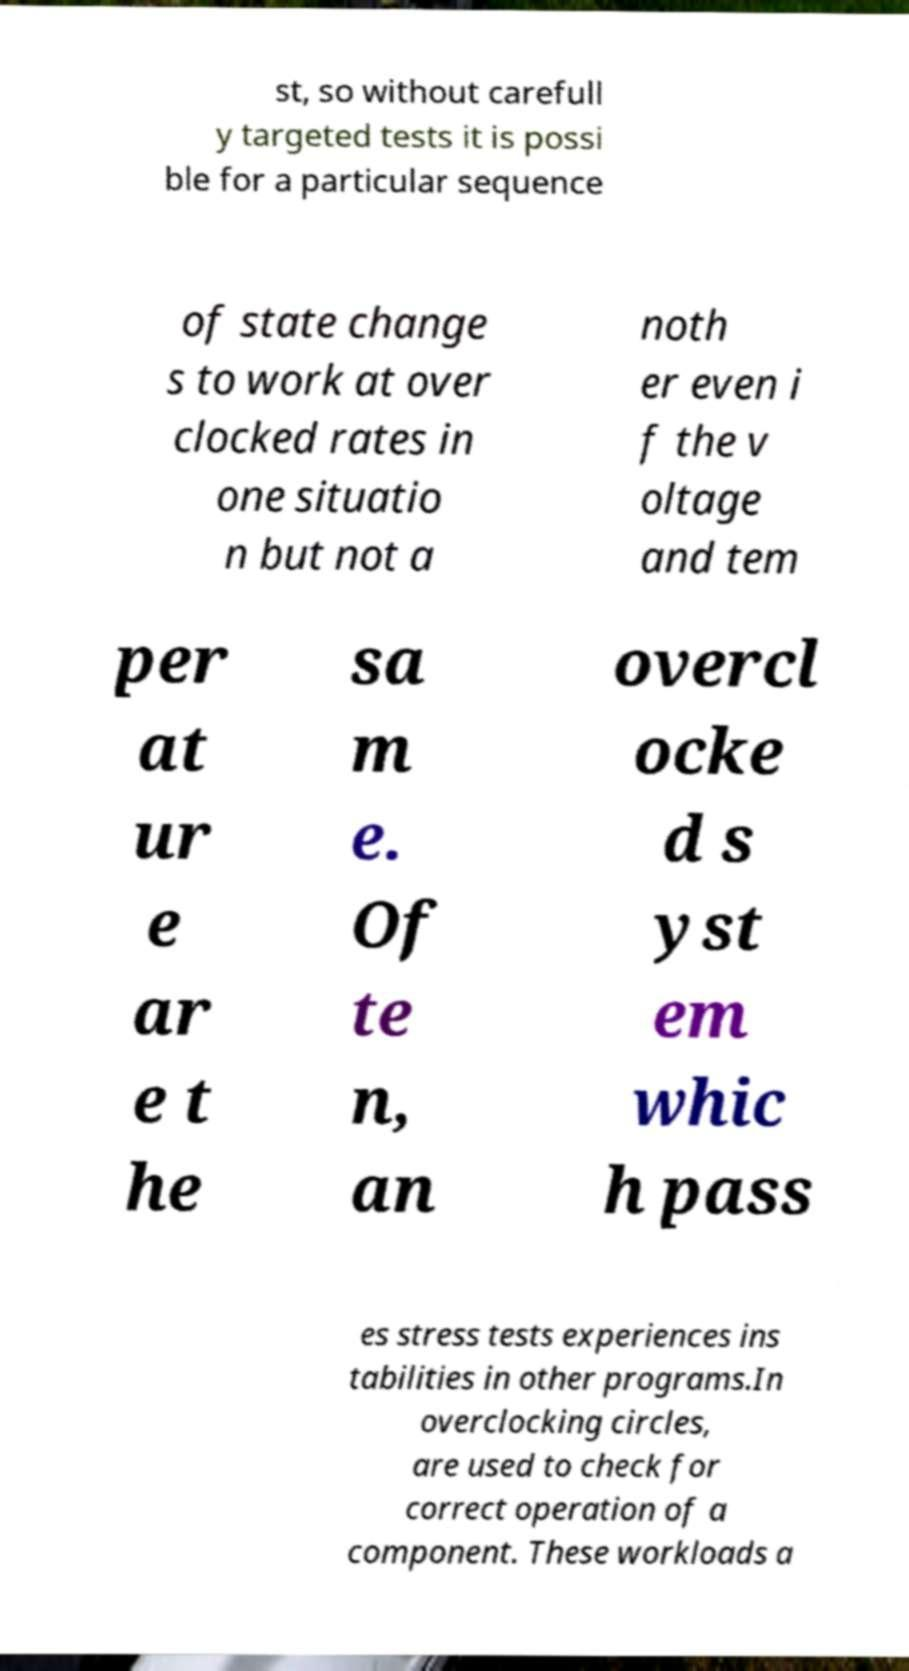I need the written content from this picture converted into text. Can you do that? st, so without carefull y targeted tests it is possi ble for a particular sequence of state change s to work at over clocked rates in one situatio n but not a noth er even i f the v oltage and tem per at ur e ar e t he sa m e. Of te n, an overcl ocke d s yst em whic h pass es stress tests experiences ins tabilities in other programs.In overclocking circles, are used to check for correct operation of a component. These workloads a 